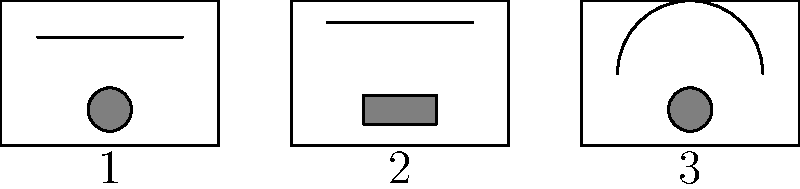Based on the cabinet designs and control layouts shown in the image, which of these vintage television sets is most likely to be a Zenith model? To identify the Zenith model among these vintage television sets, we need to analyze the distinctive features of each design:

1. TV 1 features a rectangular cabinet with a horizontal line across the upper part of the screen and a circular control knob at the bottom center. This design is typical of Philips televisions from the 1950s and 1960s.

2. TV 2 has a rectangular cabinet with a horizontal line near the top of the screen and a rectangular control panel at the bottom. This layout is characteristic of RCA television sets from the same era.

3. TV 3 displays a rectangular cabinet with a distinctive arched top on the screen area and a circular control knob at the bottom center. This unique combination of an arched screen frame and centrally positioned circular knob is a hallmark of Zenith televisions from the 1950s and early 1960s.

The arched top, in particular, was a signature design element for Zenith, often referred to as the "Space Command" design in their marketing materials. This feature set Zenith apart from other manufacturers of the time and made their televisions easily recognizable.

Therefore, based on these design characteristics, TV 3 is most likely to be a Zenith model.
Answer: TV 3 